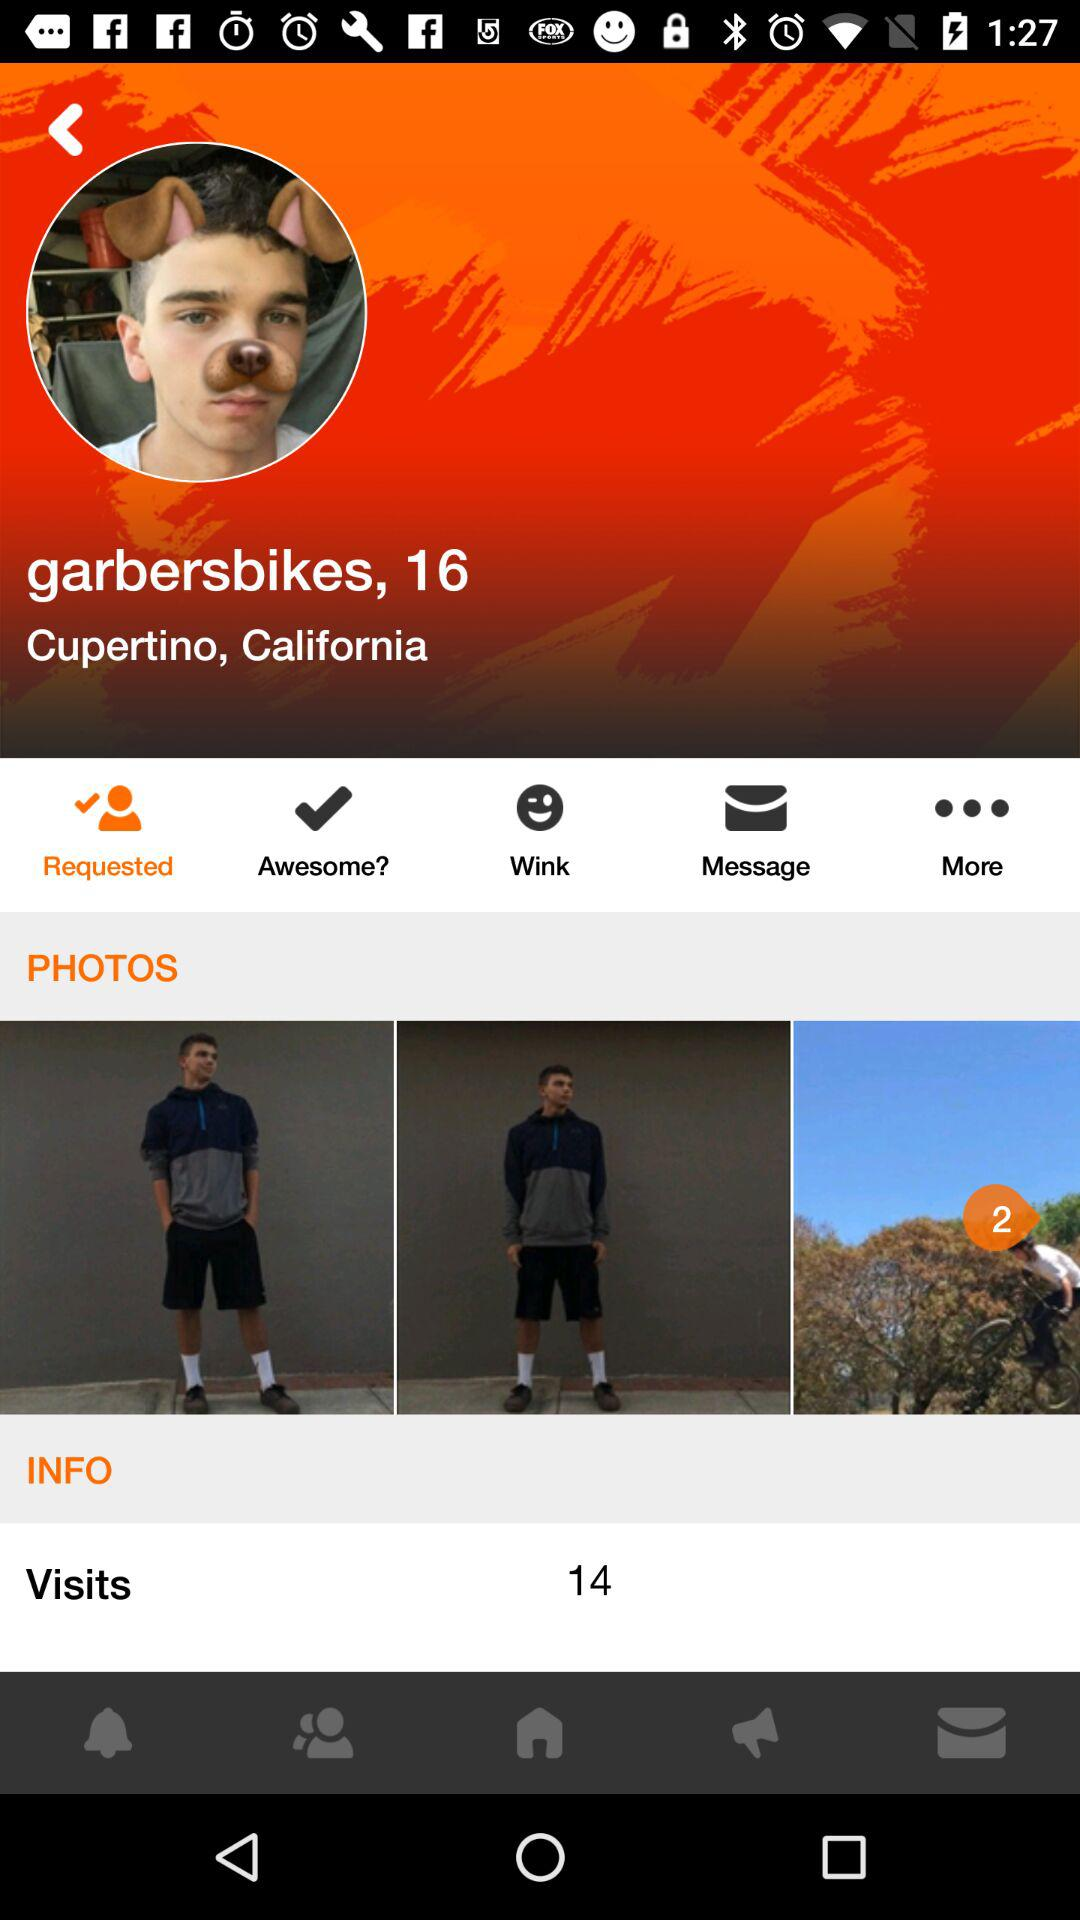What is the age of "garbersbikes"? "garbersbikes" is 16 years old. 